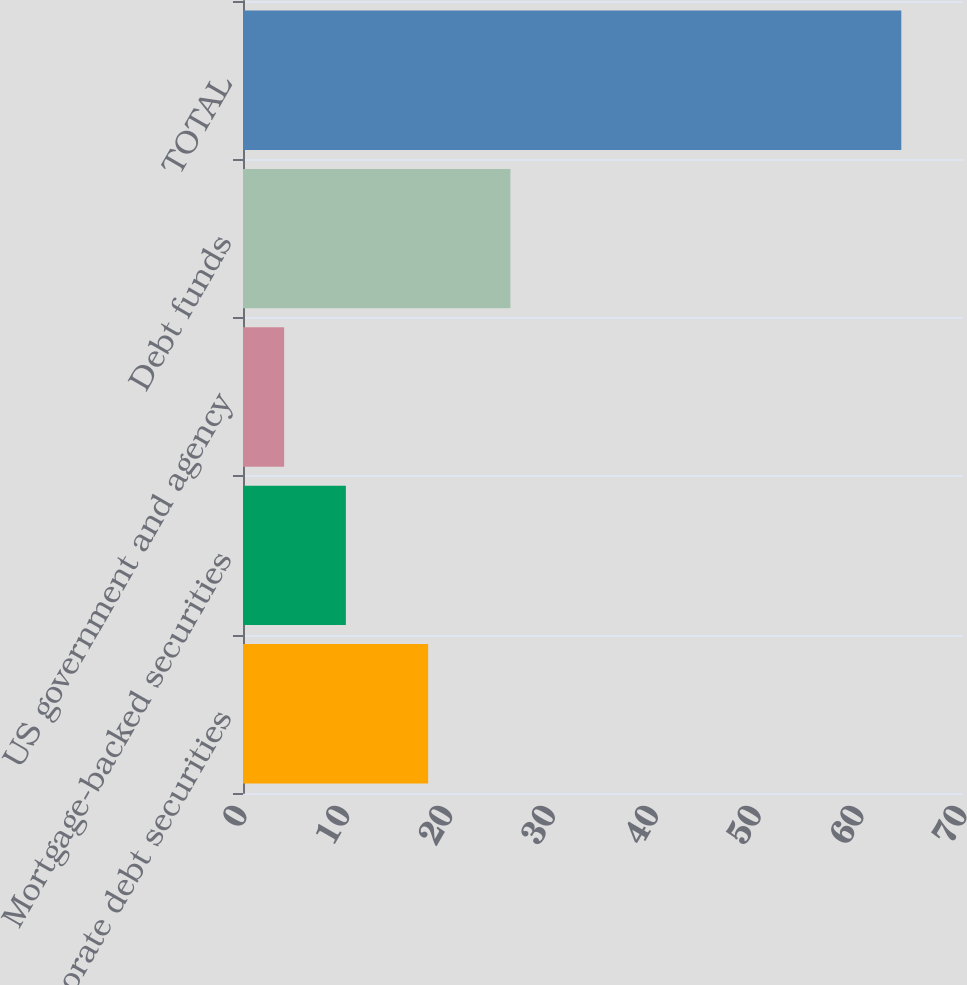Convert chart to OTSL. <chart><loc_0><loc_0><loc_500><loc_500><bar_chart><fcel>Corporate debt securities<fcel>Mortgage-backed securities<fcel>US government and agency<fcel>Debt funds<fcel>TOTAL<nl><fcel>18<fcel>10<fcel>4<fcel>26<fcel>64<nl></chart> 